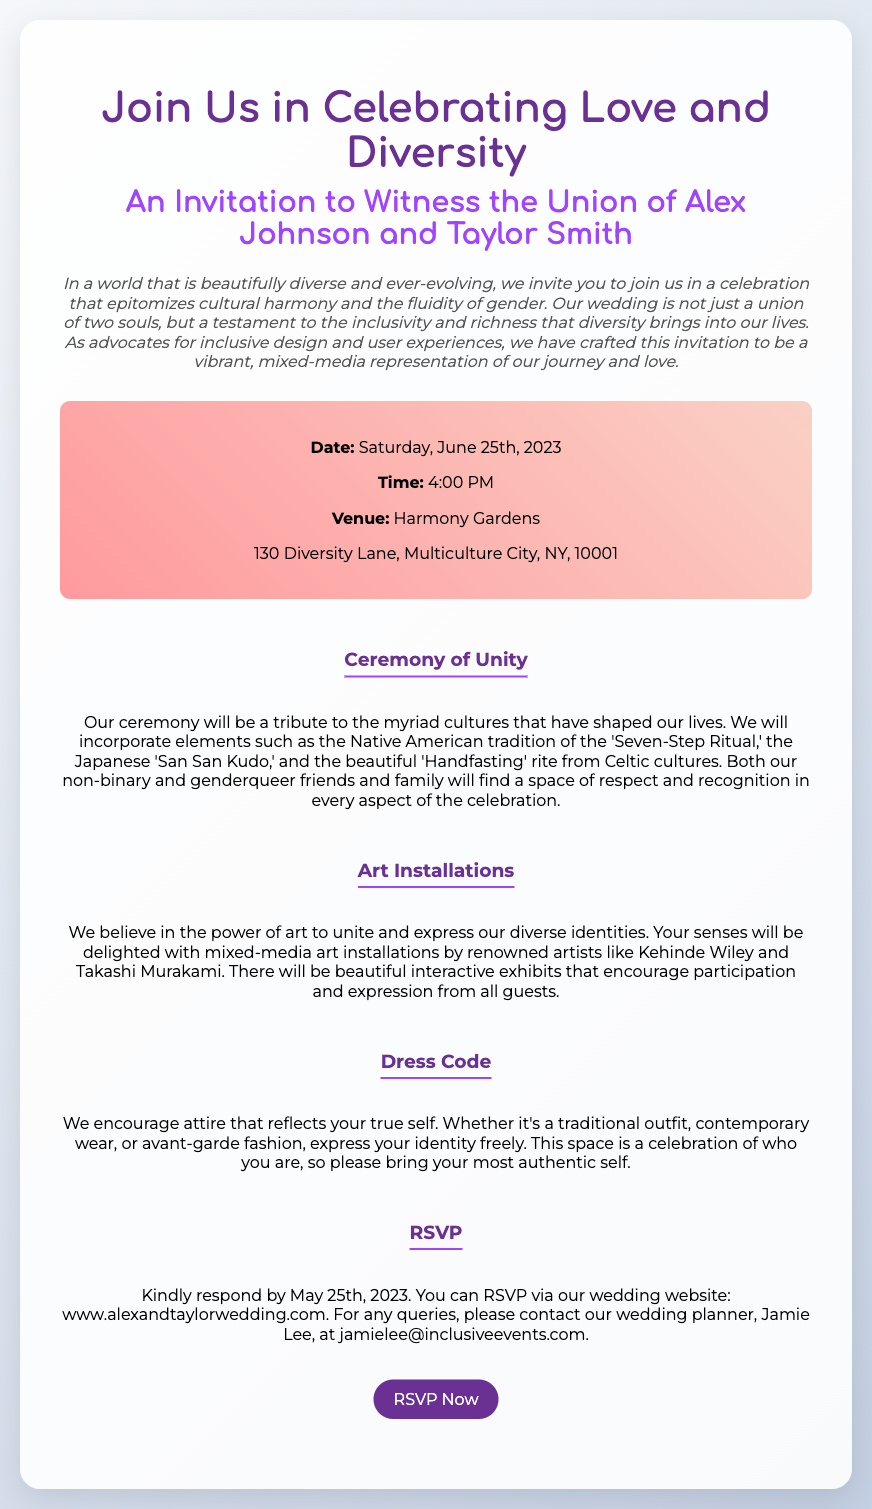What are the names of the couple getting married? The names mentioned in the document are Alex Johnson and Taylor Smith.
Answer: Alex Johnson and Taylor Smith What date is the wedding scheduled for? The wedding date stated in the document is June 25th, 2023.
Answer: June 25th, 2023 What is the venue of the ceremony? The invitation specifies "Harmony Gardens" as the venue for the wedding.
Answer: Harmony Gardens What is the dress code for the event? The document encourages attire that reflects the guests' true self without restrictions.
Answer: Attire that reflects your true self What tradition from Native American culture will be included in the ceremony? The document references the 'Seven-Step Ritual' as a Native American tradition.
Answer: Seven-Step Ritual How should guests respond by in the RSVP? The RSVP deadline given in the document is May 25th, 2023.
Answer: May 25th, 2023 What kind of art installations will be featured at the wedding? The invitation mentions mixed-media art installations by renowned artists.
Answer: Mixed-media art installations What is encouraged regarding the attire for guests? The invitation suggests that guests should express their identity freely through their attire.
Answer: Express your identity freely What interactive aspect is included in the art installations? The document states that there will be interactive exhibits that encourage participation.
Answer: Interactive exhibits 